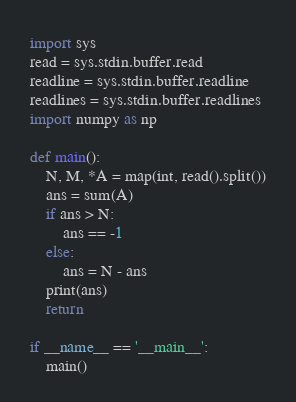Convert code to text. <code><loc_0><loc_0><loc_500><loc_500><_Python_>import sys
read = sys.stdin.buffer.read
readline = sys.stdin.buffer.readline
readlines = sys.stdin.buffer.readlines
import numpy as np

def main():
    N, M, *A = map(int, read().split())
    ans = sum(A)
    if ans > N:
        ans == -1
    else:
        ans = N - ans
    print(ans)
    return

if __name__ == '__main__':
    main()

</code> 